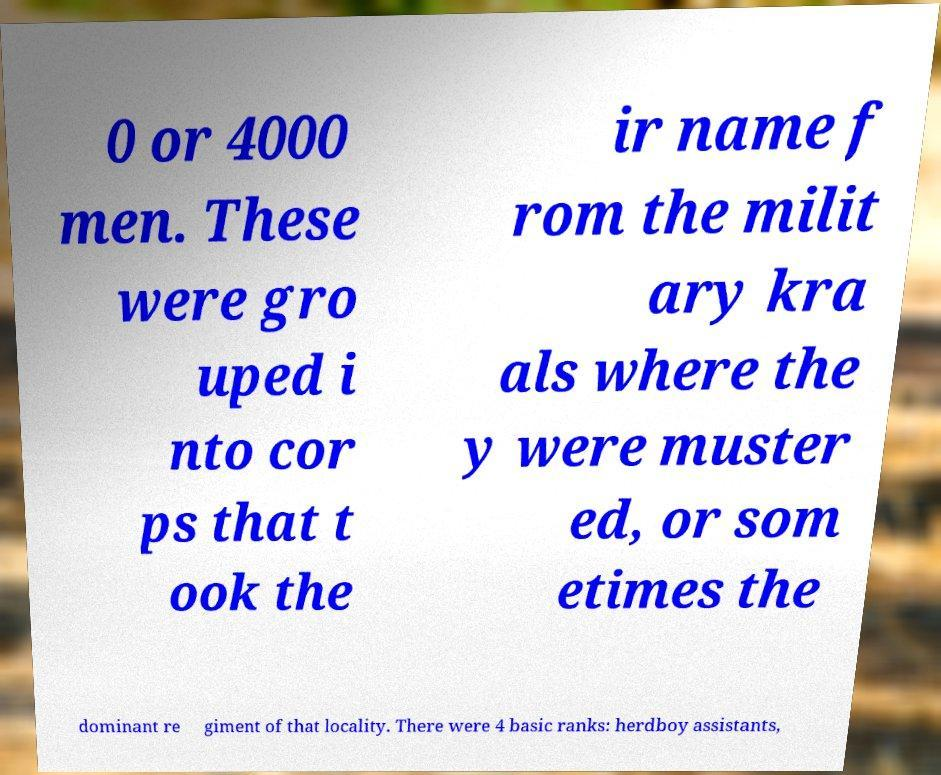Can you read and provide the text displayed in the image?This photo seems to have some interesting text. Can you extract and type it out for me? 0 or 4000 men. These were gro uped i nto cor ps that t ook the ir name f rom the milit ary kra als where the y were muster ed, or som etimes the dominant re giment of that locality. There were 4 basic ranks: herdboy assistants, 